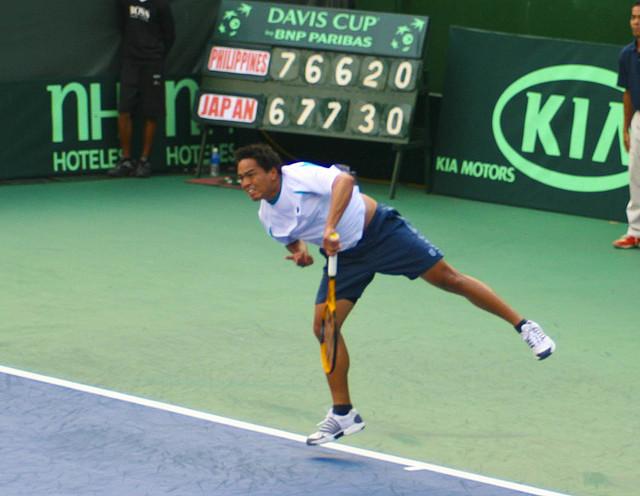What sport is being played?
Short answer required. Tennis. What shot is this player hitting?
Keep it brief. Tennis. What automobile company is a sponsor?
Be succinct. Kia. What countries are represented in the game?
Keep it brief. Philippines and japan. 